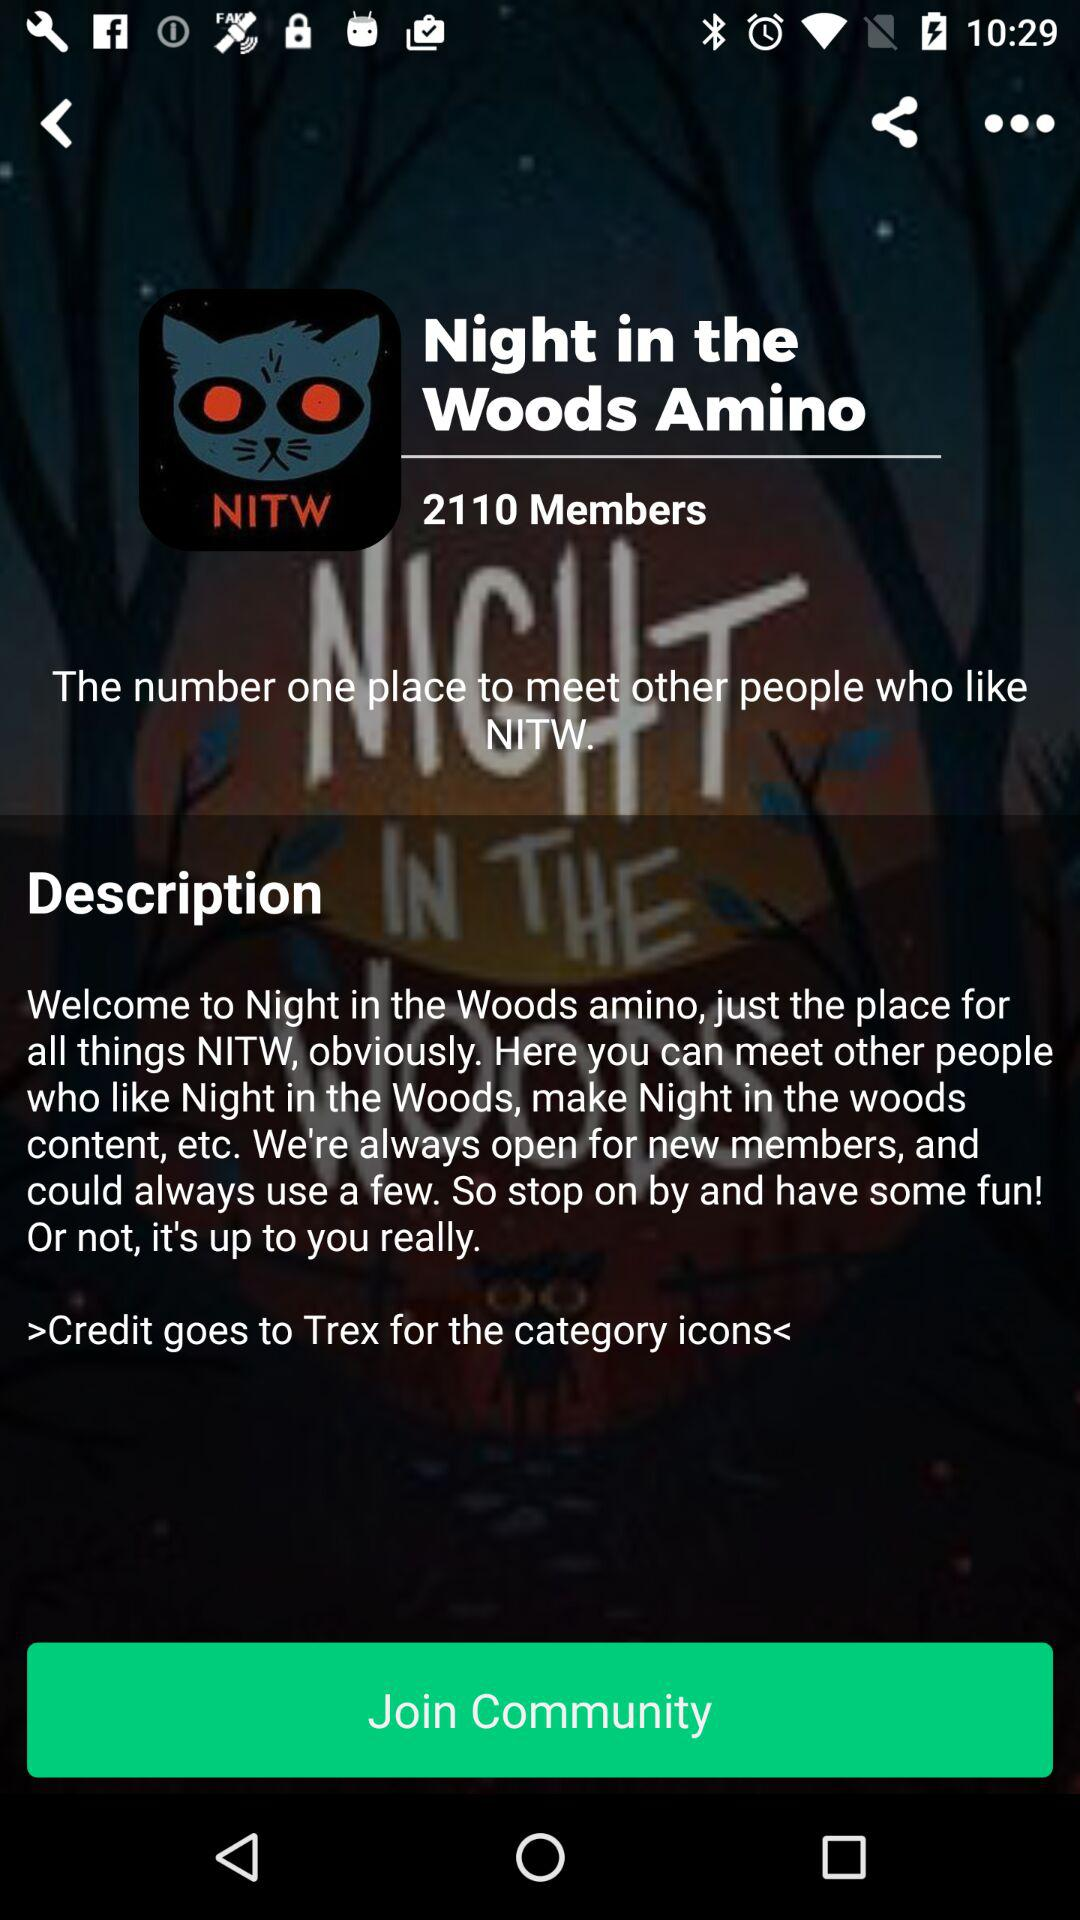What is the name of the community? The name of the community is "Night in the Woods Amino". 